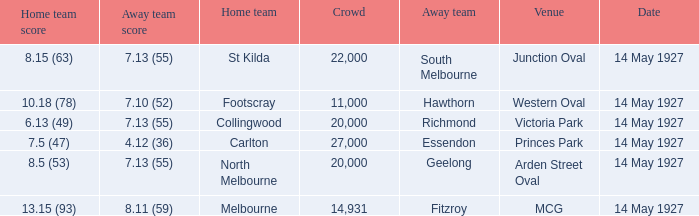Which away team had a score of 4.12 (36)? Essendon. 